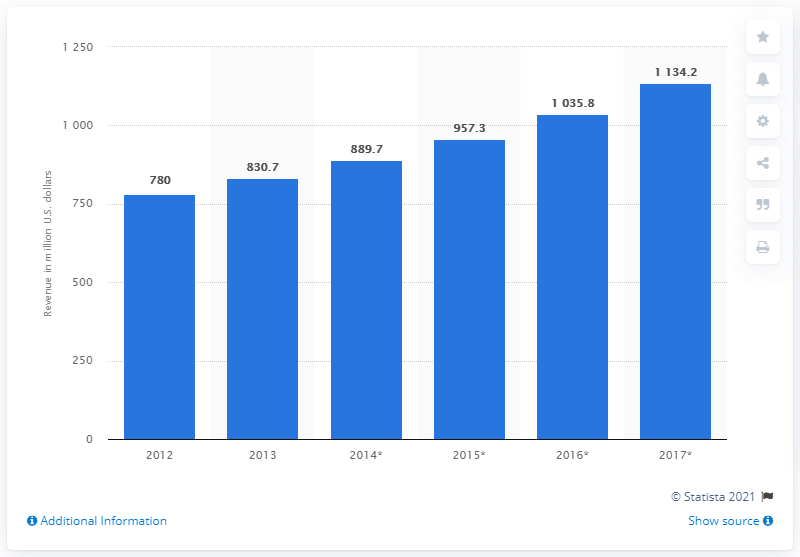Point out several critical features in this image. In 2014, the estimated revenue of the European data center cooling market was approximately 889.7 million dollars. 